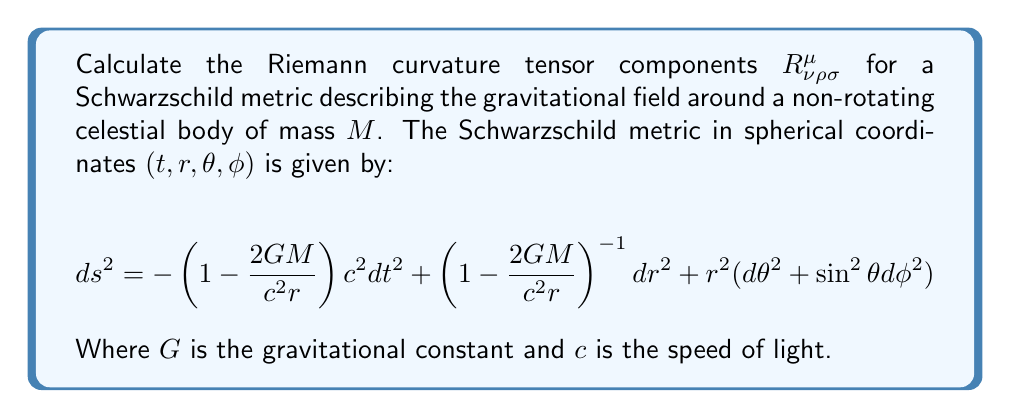Can you solve this math problem? To calculate the Riemann curvature tensor, we'll follow these steps:

1) First, we need to identify the metric components $g_{\mu\nu}$:
   $$g_{tt} = -\left(1-\frac{2GM}{c^2r}\right)$$
   $$g_{rr} = \left(1-\frac{2GM}{c^2r}\right)^{-1}$$
   $$g_{\theta\theta} = r^2$$
   $$g_{\phi\phi} = r^2\sin^2\theta$$

2) Calculate the Christoffel symbols $\Gamma^\mu_{\nu\rho}$ using:
   $$\Gamma^\mu_{\nu\rho} = \frac{1}{2}g^{\mu\sigma}(\partial_\nu g_{\sigma\rho} + \partial_\rho g_{\sigma\nu} - \partial_\sigma g_{\nu\rho})$$

3) The non-zero Christoffel symbols are:
   $$\Gamma^t_{tr} = \Gamma^t_{rt} = \frac{GM}{c^2r^2\left(1-\frac{2GM}{c^2r}\right)}$$
   $$\Gamma^r_{tt} = \frac{GM}{c^2r^2}\left(1-\frac{2GM}{c^2r}\right)$$
   $$\Gamma^r_{rr} = -\frac{GM}{c^2r^2}\left(1-\frac{2GM}{c^2r}\right)^{-1}$$
   $$\Gamma^r_{\theta\theta} = -r\left(1-\frac{2GM}{c^2r}\right)$$
   $$\Gamma^r_{\phi\phi} = -r\sin^2\theta\left(1-\frac{2GM}{c^2r}\right)$$
   $$\Gamma^\theta_{r\theta} = \Gamma^\theta_{\theta r} = \frac{1}{r}$$
   $$\Gamma^\theta_{\phi\phi} = -\sin\theta\cos\theta$$
   $$\Gamma^\phi_{r\phi} = \Gamma^\phi_{\phi r} = \frac{1}{r}$$
   $$\Gamma^\phi_{\theta\phi} = \Gamma^\phi_{\phi\theta} = \cot\theta$$

4) Calculate the Riemann tensor using:
   $$R^\mu_{\nu\rho\sigma} = \partial_\rho\Gamma^\mu_{\nu\sigma} - \partial_\sigma\Gamma^\mu_{\nu\rho} + \Gamma^\mu_{\lambda\rho}\Gamma^\lambda_{\nu\sigma} - \Gamma^\mu_{\lambda\sigma}\Gamma^\lambda_{\nu\rho}$$

5) The non-zero components of the Riemann tensor are:
   $$R^t_{rtr} = -R^t_{rrt} = \frac{2GM}{c^2r^3}$$
   $$R^r_{trt} = -R^r_{ttr} = \frac{2GM}{c^2r^3}\left(1-\frac{2GM}{c^2r}\right)$$
   $$R^r_{\theta r\theta} = -R^r_{\theta\theta r} = -\frac{GM}{c^2r}$$
   $$R^r_{\phi r\phi} = -R^r_{\phi\phi r} = -\frac{GM}{c^2r}\sin^2\theta$$
   $$R^\theta_{\phi\theta\phi} = -R^\theta_{\phi\phi\theta} = \frac{2GM}{c^2r}\sin^2\theta$$
   $$R^\phi_{r\phi r} = -R^\phi_{rr\phi} = -\frac{GM}{c^2r}$$
   $$R^\phi_{\theta\phi\theta} = -R^\phi_{\theta\theta\phi} = -\frac{GM}{c^2r}\sin^2\theta$$

These components fully describe the curvature of spacetime around a non-rotating celestial body in the Schwarzschild metric.
Answer: $R^t_{rtr} = -R^t_{rrt} = \frac{2GM}{c^2r^3}$, $R^r_{trt} = -R^r_{ttr} = \frac{2GM}{c^2r^3}\left(1-\frac{2GM}{c^2r}\right)$, $R^r_{\theta r\theta} = -R^r_{\theta\theta r} = -\frac{GM}{c^2r}$, $R^r_{\phi r\phi} = -R^r_{\phi\phi r} = -\frac{GM}{c^2r}\sin^2\theta$, $R^\theta_{\phi\theta\phi} = -R^\theta_{\phi\phi\theta} = \frac{2GM}{c^2r}\sin^2\theta$, $R^\phi_{r\phi r} = -R^\phi_{rr\phi} = -\frac{GM}{c^2r}$, $R^\phi_{\theta\phi\theta} = -R^\phi_{\theta\theta\phi} = -\frac{GM}{c^2r}\sin^2\theta$ 